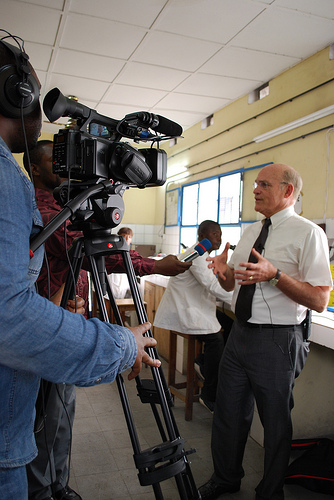<image>
Is there a tie on the man? No. The tie is not positioned on the man. They may be near each other, but the tie is not supported by or resting on top of the man. Is there a camera next to the tripod? No. The camera is not positioned next to the tripod. They are located in different areas of the scene. 